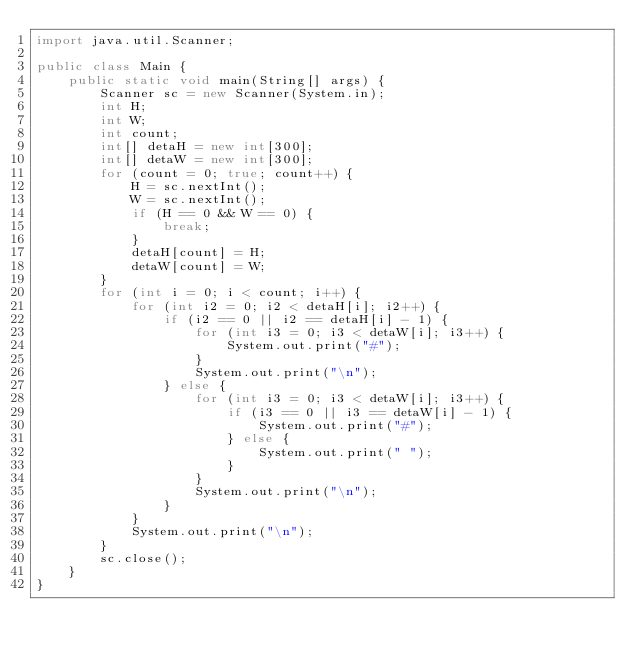<code> <loc_0><loc_0><loc_500><loc_500><_Java_>import java.util.Scanner;

public class Main {
	public static void main(String[] args) {
		Scanner sc = new Scanner(System.in);
		int H;
		int W;
		int count;
		int[] detaH = new int[300];
		int[] detaW = new int[300];
		for (count = 0; true; count++) {
			H = sc.nextInt();
			W = sc.nextInt();
			if (H == 0 && W == 0) {
				break;
			}
			detaH[count] = H;
			detaW[count] = W;
		}
		for (int i = 0; i < count; i++) {
			for (int i2 = 0; i2 < detaH[i]; i2++) {
				if (i2 == 0 || i2 == detaH[i] - 1) {
					for (int i3 = 0; i3 < detaW[i]; i3++) {
						System.out.print("#");
					}
					System.out.print("\n");
				} else {
					for (int i3 = 0; i3 < detaW[i]; i3++) {
						if (i3 == 0 || i3 == detaW[i] - 1) {
							System.out.print("#");
						} else {
							System.out.print(" ");
						}
					}
					System.out.print("\n");
				}
			}
			System.out.print("\n");
		}
		sc.close();
	}
}
</code> 